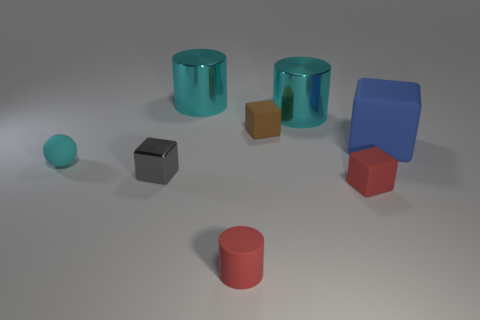Subtract all cyan cylinders. How many cylinders are left? 1 Subtract all gray cubes. How many cubes are left? 3 Add 1 large blue blocks. How many objects exist? 9 Subtract all cyan cubes. Subtract all brown spheres. How many cubes are left? 4 Subtract all cylinders. How many objects are left? 5 Subtract all big rubber objects. Subtract all large rubber objects. How many objects are left? 6 Add 2 big cyan objects. How many big cyan objects are left? 4 Add 6 large gray blocks. How many large gray blocks exist? 6 Subtract 1 gray cubes. How many objects are left? 7 